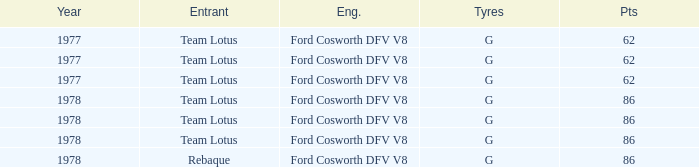What is the Motor that has a Focuses bigger than 62, and a Participant of rebaque? Ford Cosworth DFV V8. 